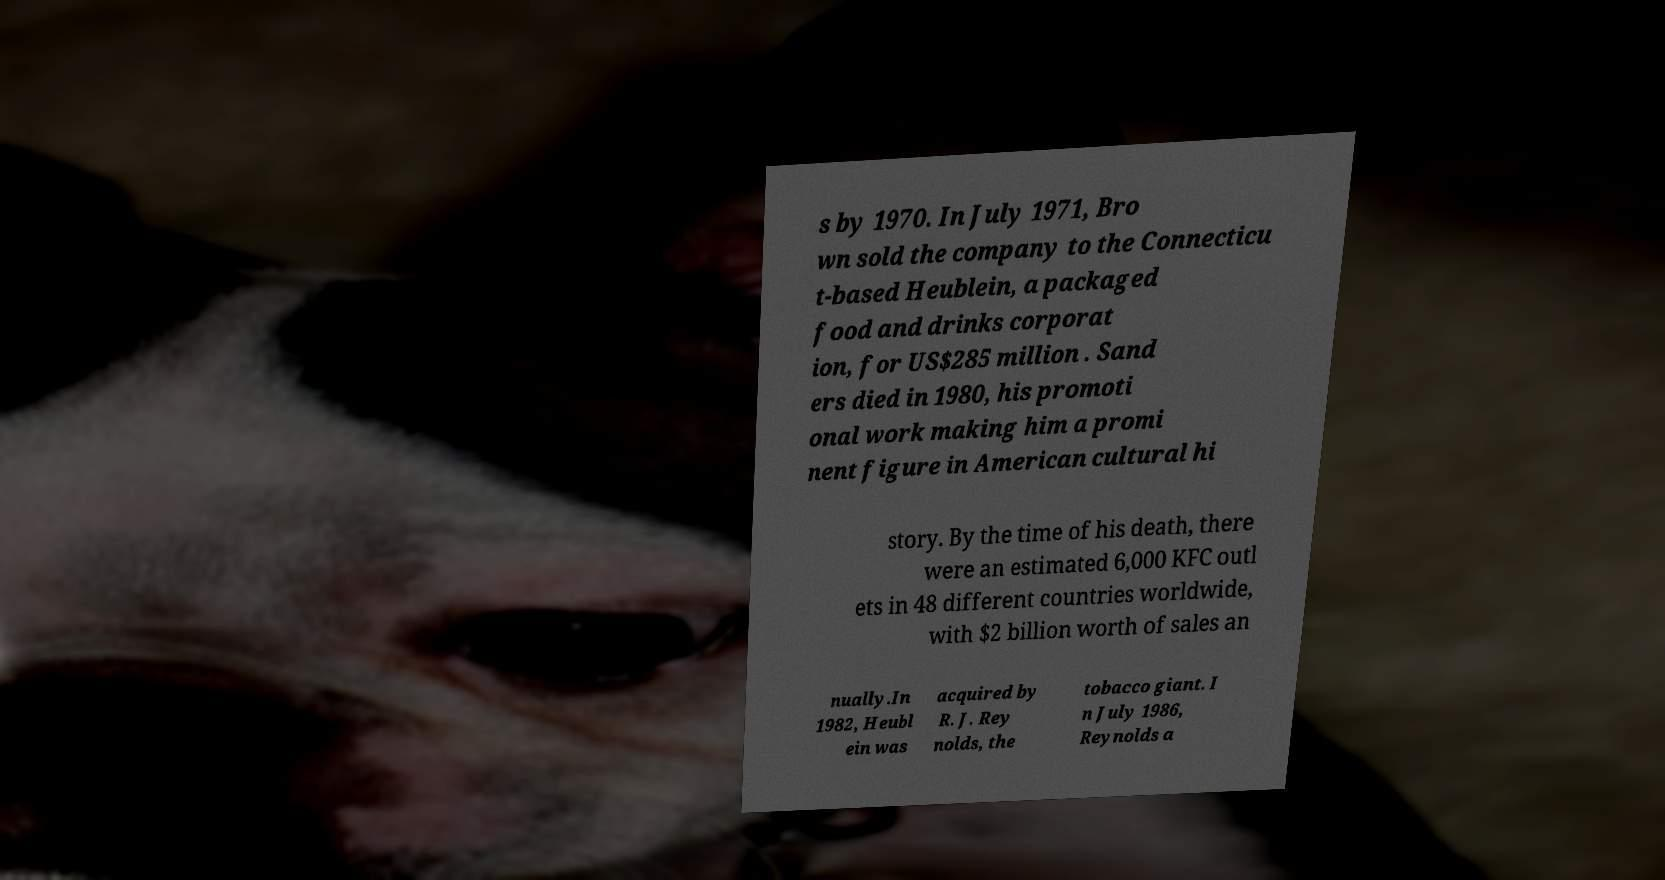There's text embedded in this image that I need extracted. Can you transcribe it verbatim? s by 1970. In July 1971, Bro wn sold the company to the Connecticu t-based Heublein, a packaged food and drinks corporat ion, for US$285 million . Sand ers died in 1980, his promoti onal work making him a promi nent figure in American cultural hi story. By the time of his death, there were an estimated 6,000 KFC outl ets in 48 different countries worldwide, with $2 billion worth of sales an nually.In 1982, Heubl ein was acquired by R. J. Rey nolds, the tobacco giant. I n July 1986, Reynolds a 